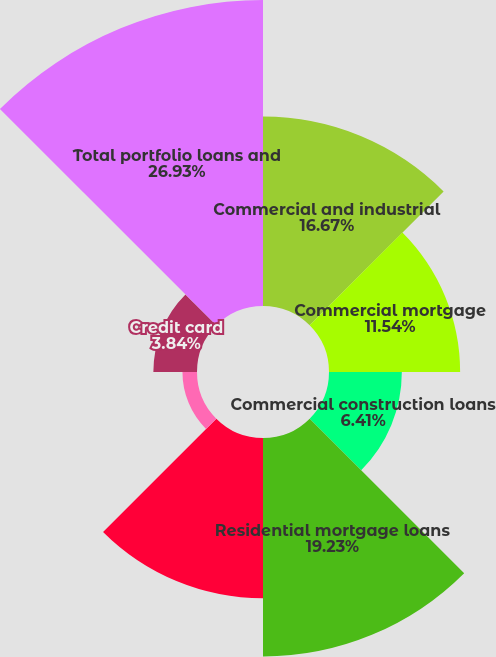<chart> <loc_0><loc_0><loc_500><loc_500><pie_chart><fcel>Commercial and industrial<fcel>Commercial mortgage<fcel>Commercial construction loans<fcel>Residential mortgage loans<fcel>Home equity<fcel>Automobile loans<fcel>Credit card<fcel>Total portfolio loans and<nl><fcel>16.67%<fcel>11.54%<fcel>6.41%<fcel>19.23%<fcel>14.1%<fcel>1.28%<fcel>3.84%<fcel>26.93%<nl></chart> 